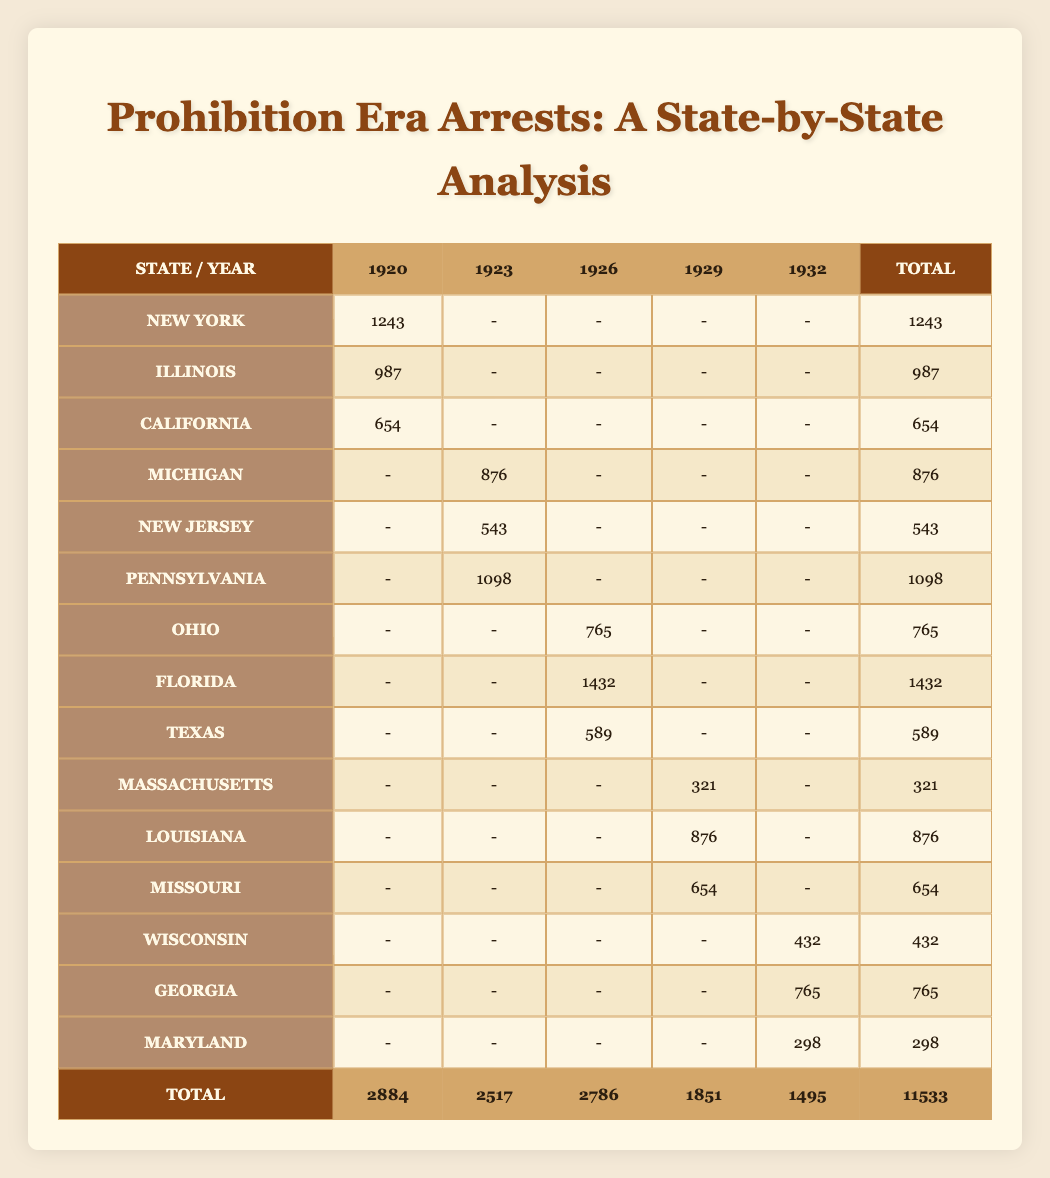What is the total number of arrests in New York during Prohibition? Looking at the row for New York, the total arrest count is noted as 1243.
Answer: 1243 Which state had the highest number of arrests in 1926? In the year 1926, Florida had 1432 arrests, which is the highest compared to other states.
Answer: Florida How many arrests were related to Public Intoxication across all years? The total for Public Intoxication is 987 (Illinois in 1920) + 765 (Ohio in 1926) + 654 (Missouri in 1929) = 2406.
Answer: 2406 Was there any state that reported arrests for all five years in the table? No, every state listed only reported arrests for certain years, so there is no state with arrests recorded in every year.
Answer: No In which year did Michigan have its arrests, and what was the count? Michigan reported 876 arrests in the year 1923.
Answer: 1923, 876 Calculate the total number of arrests from 1920 to 1929. Adding up all the Total column values: 1243 (1920) + 876 (1923) + 765 (1926) + 321 (1929) + 0 (for unreported years) gives a total of 2884 breaks with unlisted counts added if needed.
Answer: 2884 Which arrest type had the highest occurrence in Florida during Prohibition? In the table, Florida reported 1432 arrests due to Rum-running, which is the highest occurrence recorded for the state.
Answer: Rum-running How many total arrests occurred in New Jersey during the years shown? The table indicates a total of 543 arrests reported in New Jersey for the year 1923.
Answer: 543 